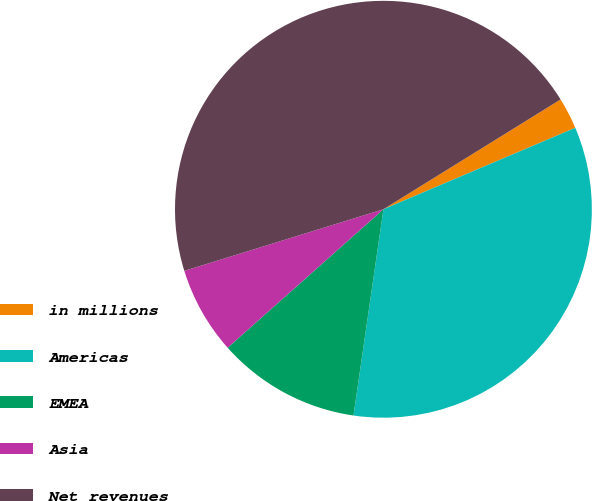Convert chart to OTSL. <chart><loc_0><loc_0><loc_500><loc_500><pie_chart><fcel>in millions<fcel>Americas<fcel>EMEA<fcel>Asia<fcel>Net revenues<nl><fcel>2.44%<fcel>33.68%<fcel>11.14%<fcel>6.79%<fcel>45.94%<nl></chart> 